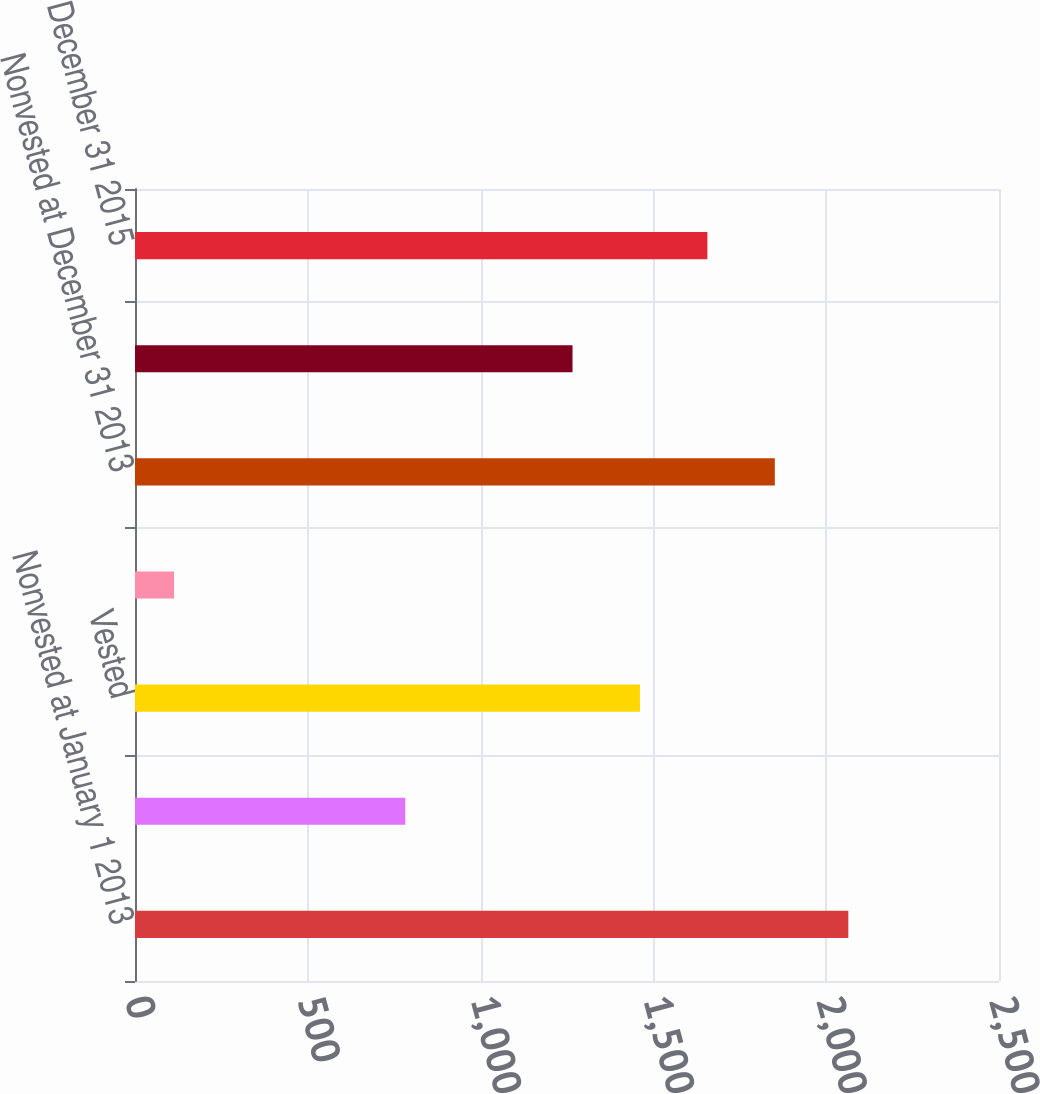Convert chart to OTSL. <chart><loc_0><loc_0><loc_500><loc_500><bar_chart><fcel>Nonvested at January 1 2013<fcel>Granted<fcel>Vested<fcel>Forfeited<fcel>Nonvested at December 31 2013<fcel>Nonvested at December 31 2014<fcel>Nonvested at December 31 2015<nl><fcel>2064<fcel>782<fcel>1461.1<fcel>113<fcel>1851.3<fcel>1266<fcel>1656.2<nl></chart> 